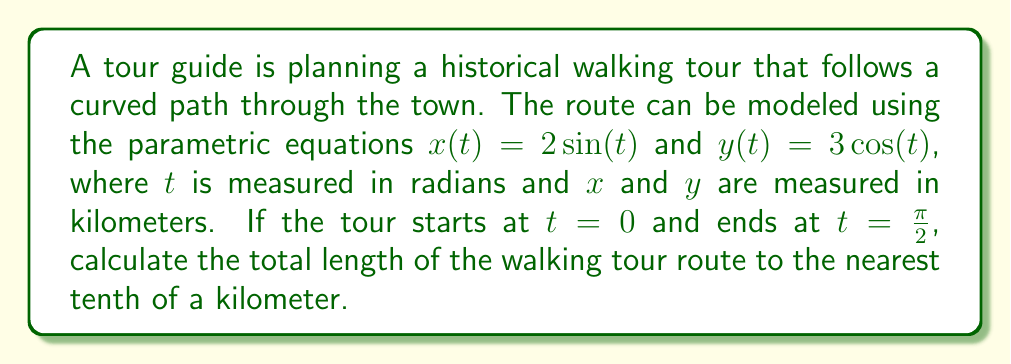Can you solve this math problem? To calculate the length of a curve defined by parametric equations, we use the arc length formula:

$$ L = \int_{a}^{b} \sqrt{\left(\frac{dx}{dt}\right)^2 + \left(\frac{dy}{dt}\right)^2} dt $$

Where $a$ and $b$ are the starting and ending values of $t$.

Step 1: Find $\frac{dx}{dt}$ and $\frac{dy}{dt}$
$\frac{dx}{dt} = 2\cos(t)$
$\frac{dy}{dt} = -3\sin(t)$

Step 2: Substitute these into the arc length formula
$$ L = \int_{0}^{\frac{\pi}{2}} \sqrt{(2\cos(t))^2 + (-3\sin(t))^2} dt $$

Step 3: Simplify under the square root
$$ L = \int_{0}^{\frac{\pi}{2}} \sqrt{4\cos^2(t) + 9\sin^2(t)} dt $$

Step 4: Factor out the common term
$$ L = \int_{0}^{\frac{\pi}{2}} \sqrt{9(\frac{4}{9}\cos^2(t) + \sin^2(t))} dt $$
$$ L = 3\int_{0}^{\frac{\pi}{2}} \sqrt{\frac{4}{9}\cos^2(t) + \sin^2(t)} dt $$

Step 5: Recognize that this integral doesn't have a simple antiderivative. We need to use numerical integration methods or a calculator with integration capabilities.

Using a calculator or computer algebra system, we find:
$$ L \approx 3.9088 \text{ km} $$

Rounding to the nearest tenth of a kilometer gives 3.9 km.
Answer: The total length of the walking tour route is approximately 3.9 km. 